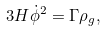<formula> <loc_0><loc_0><loc_500><loc_500>3 H \dot { \phi } ^ { 2 } = \Gamma \rho _ { g } ,</formula> 